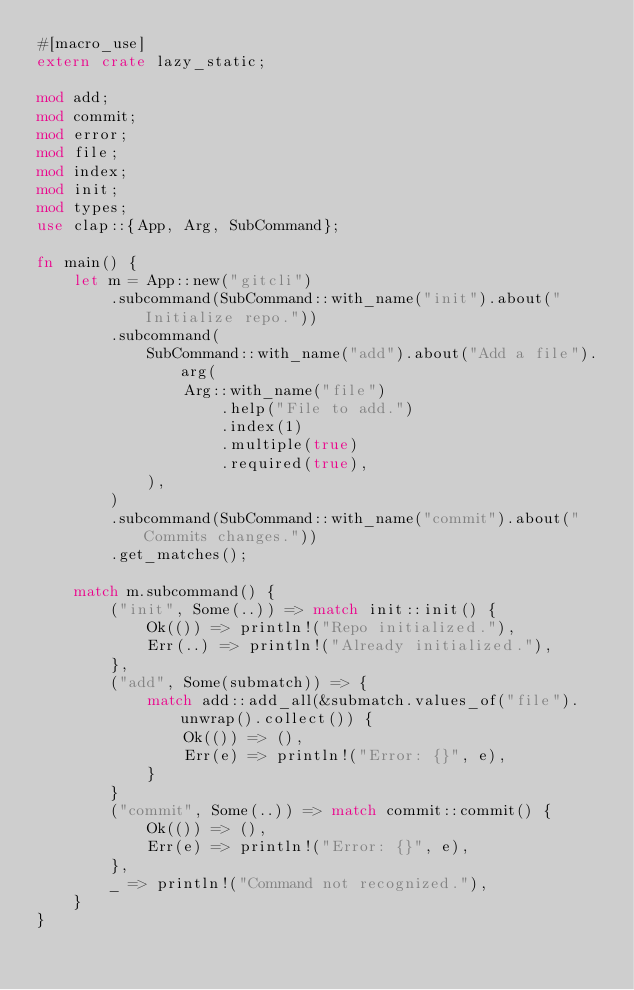<code> <loc_0><loc_0><loc_500><loc_500><_Rust_>#[macro_use]
extern crate lazy_static;

mod add;
mod commit;
mod error;
mod file;
mod index;
mod init;
mod types;
use clap::{App, Arg, SubCommand};

fn main() {
    let m = App::new("gitcli")
        .subcommand(SubCommand::with_name("init").about("Initialize repo."))
        .subcommand(
            SubCommand::with_name("add").about("Add a file").arg(
                Arg::with_name("file")
                    .help("File to add.")
                    .index(1)
                    .multiple(true)
                    .required(true),
            ),
        )
        .subcommand(SubCommand::with_name("commit").about("Commits changes."))
        .get_matches();

    match m.subcommand() {
        ("init", Some(..)) => match init::init() {
            Ok(()) => println!("Repo initialized."),
            Err(..) => println!("Already initialized."),
        },
        ("add", Some(submatch)) => {
            match add::add_all(&submatch.values_of("file").unwrap().collect()) {
                Ok(()) => (),
                Err(e) => println!("Error: {}", e),
            }
        }
        ("commit", Some(..)) => match commit::commit() {
            Ok(()) => (),
            Err(e) => println!("Error: {}", e),
        },
        _ => println!("Command not recognized."),
    }
}
</code> 